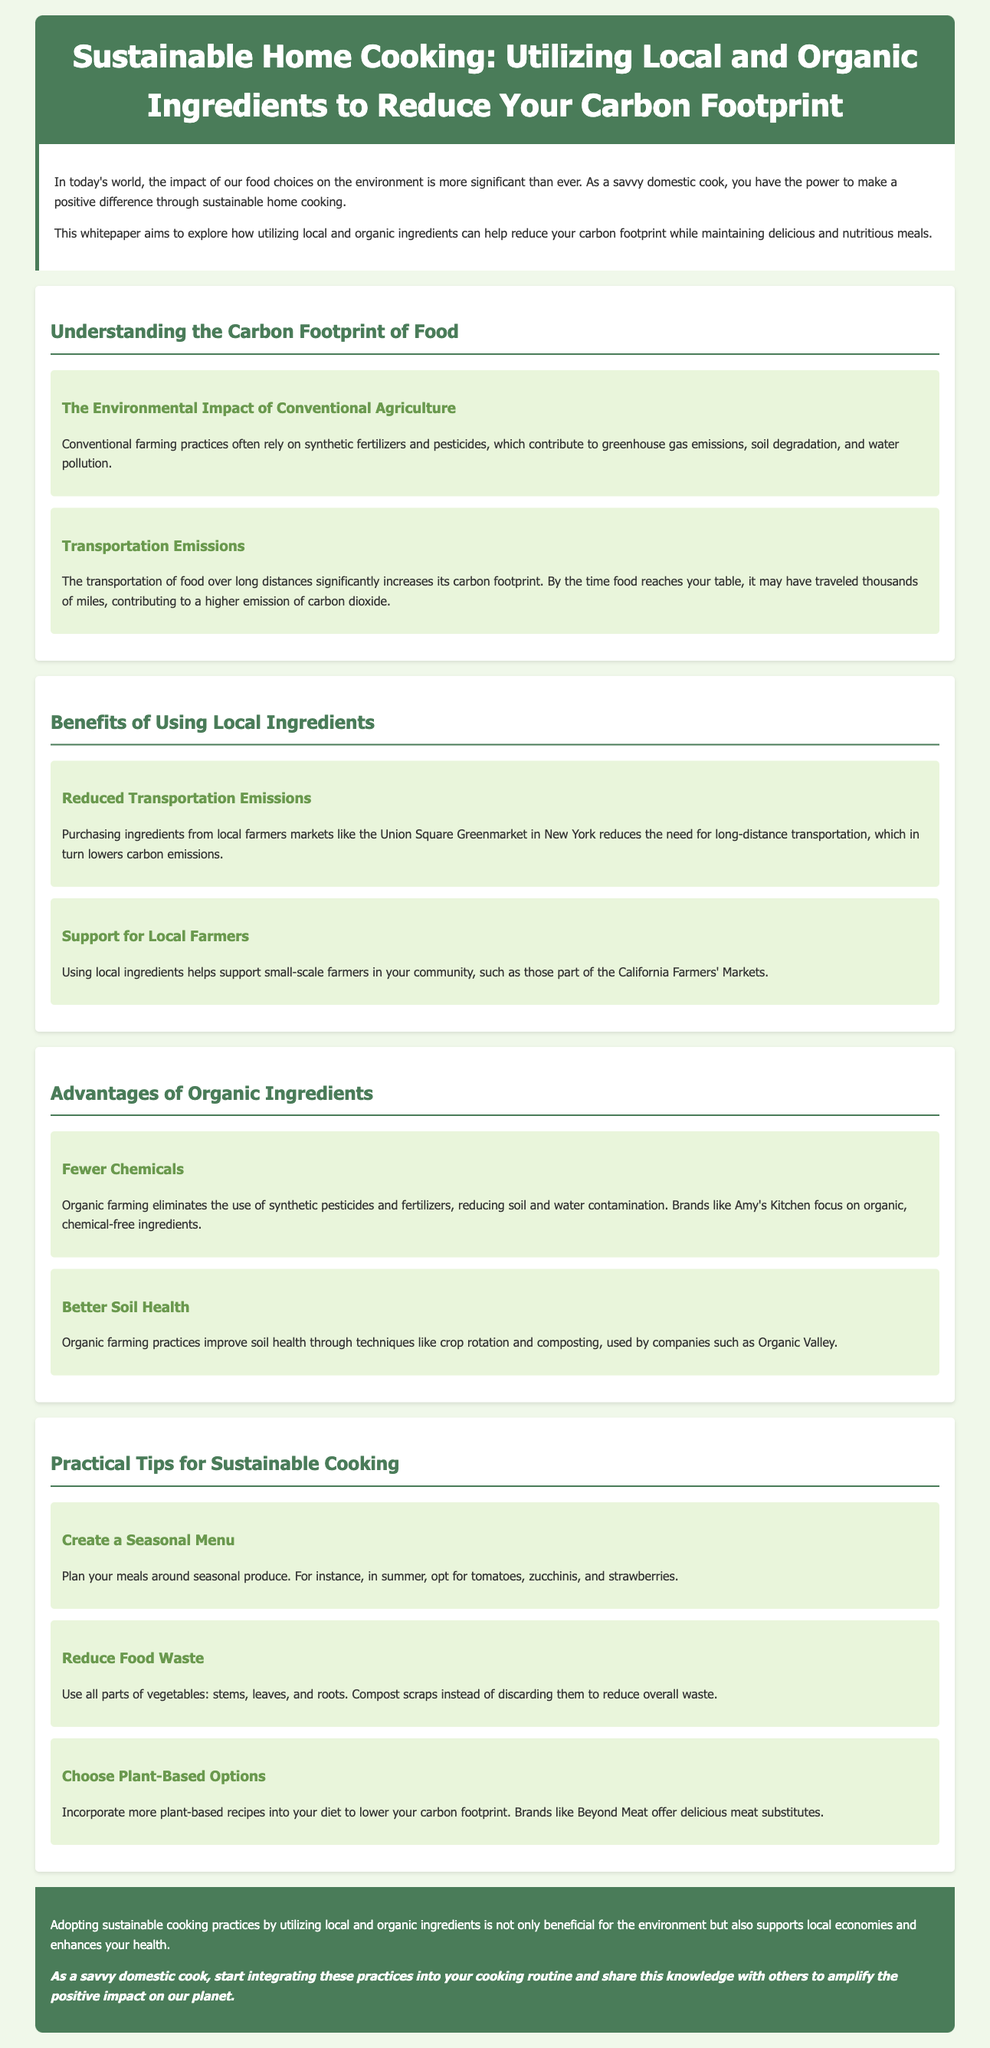what is the title of the whitepaper? The title of the whitepaper is mentioned in the header.
Answer: Sustainable Home Cooking: Utilizing Local and Organic Ingredients to Reduce Your Carbon Footprint what are the two main types of ingredients discussed? The document discusses local and organic ingredients as the two main types.
Answer: Local and organic what is the key benefit of using local ingredients mentioned? The document highlights a key benefit of reduced transportation emissions when using local ingredients.
Answer: Reduced transportation emissions which farming practices contribute to greenhouse gas emissions according to the document? The document states that conventional farming practices contribute to greenhouse gas emissions.
Answer: Conventional farming practices what is one way to reduce food waste as suggested in the whitepaper? The whitepaper suggests using all parts of vegetables as one way to reduce food waste.
Answer: Use all parts of vegetables which type of farming eliminates synthetic pesticides? The document states that organic farming eliminates the use of synthetic pesticides.
Answer: Organic farming name a farmers market mentioned in the document. The document mentions the Union Square Greenmarket in New York as a farmers market.
Answer: Union Square Greenmarket what is a recommended practice to enhance soil health? The document mentions crop rotation as a practice to enhance soil health.
Answer: Crop rotation which company focuses on organic, chemical-free ingredients? The document states that Amy's Kitchen focuses on organic, chemical-free ingredients.
Answer: Amy's Kitchen 